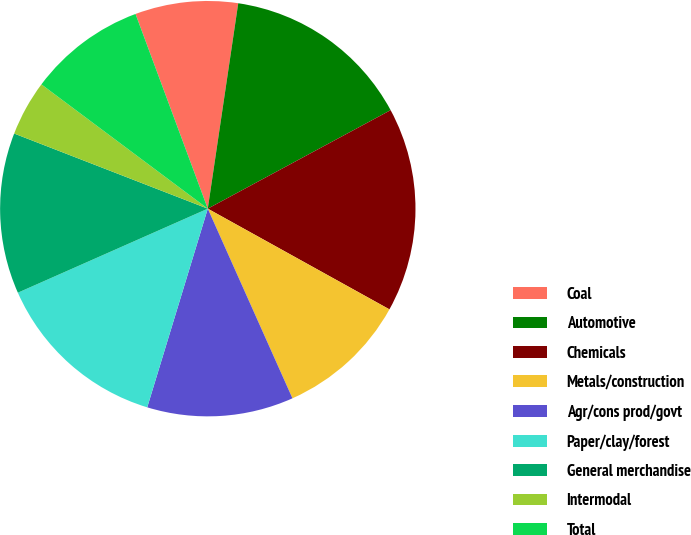Convert chart to OTSL. <chart><loc_0><loc_0><loc_500><loc_500><pie_chart><fcel>Coal<fcel>Automotive<fcel>Chemicals<fcel>Metals/construction<fcel>Agr/cons prod/govt<fcel>Paper/clay/forest<fcel>General merchandise<fcel>Intermodal<fcel>Total<nl><fcel>8.0%<fcel>14.79%<fcel>15.92%<fcel>10.26%<fcel>11.39%<fcel>13.66%<fcel>12.52%<fcel>4.32%<fcel>9.13%<nl></chart> 